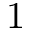Convert formula to latex. <formula><loc_0><loc_0><loc_500><loc_500>1</formula> 